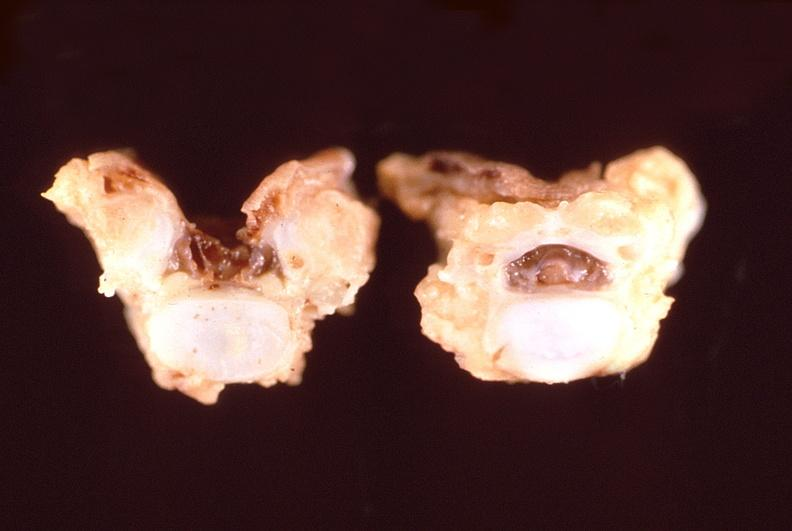does pierre robin sndrome show neural tube defect, vertebral bodies?
Answer the question using a single word or phrase. No 